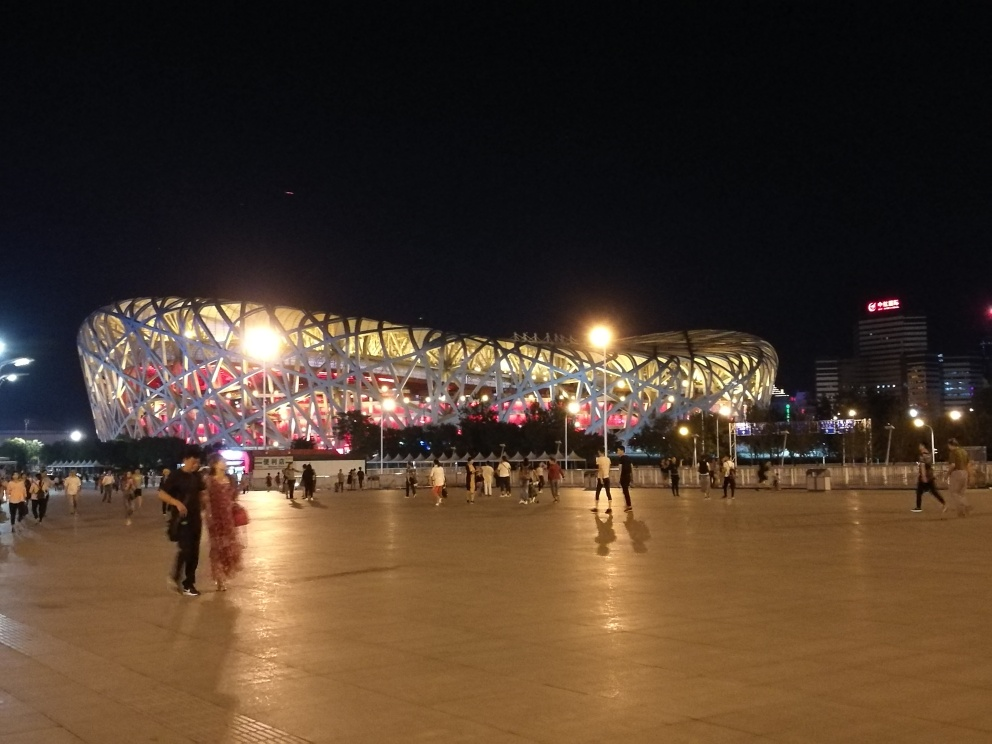How does the lighting affect the atmosphere of the place? The lighting creates a vibrant atmosphere, casting colorful reflections and drawing attention to the intricate patterns of the structure, which makes the building a visually striking centerpiece in the evening. 